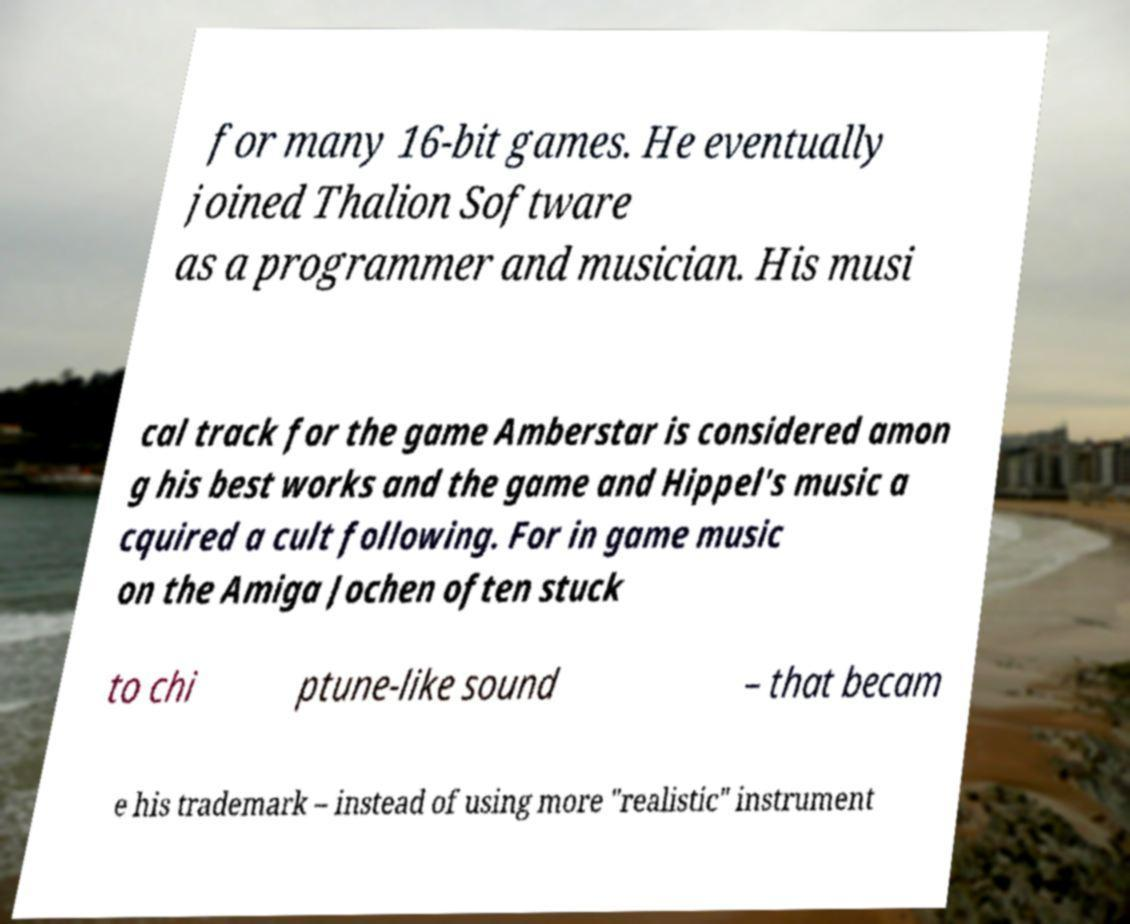What messages or text are displayed in this image? I need them in a readable, typed format. for many 16-bit games. He eventually joined Thalion Software as a programmer and musician. His musi cal track for the game Amberstar is considered amon g his best works and the game and Hippel's music a cquired a cult following. For in game music on the Amiga Jochen often stuck to chi ptune-like sound – that becam e his trademark – instead of using more "realistic" instrument 